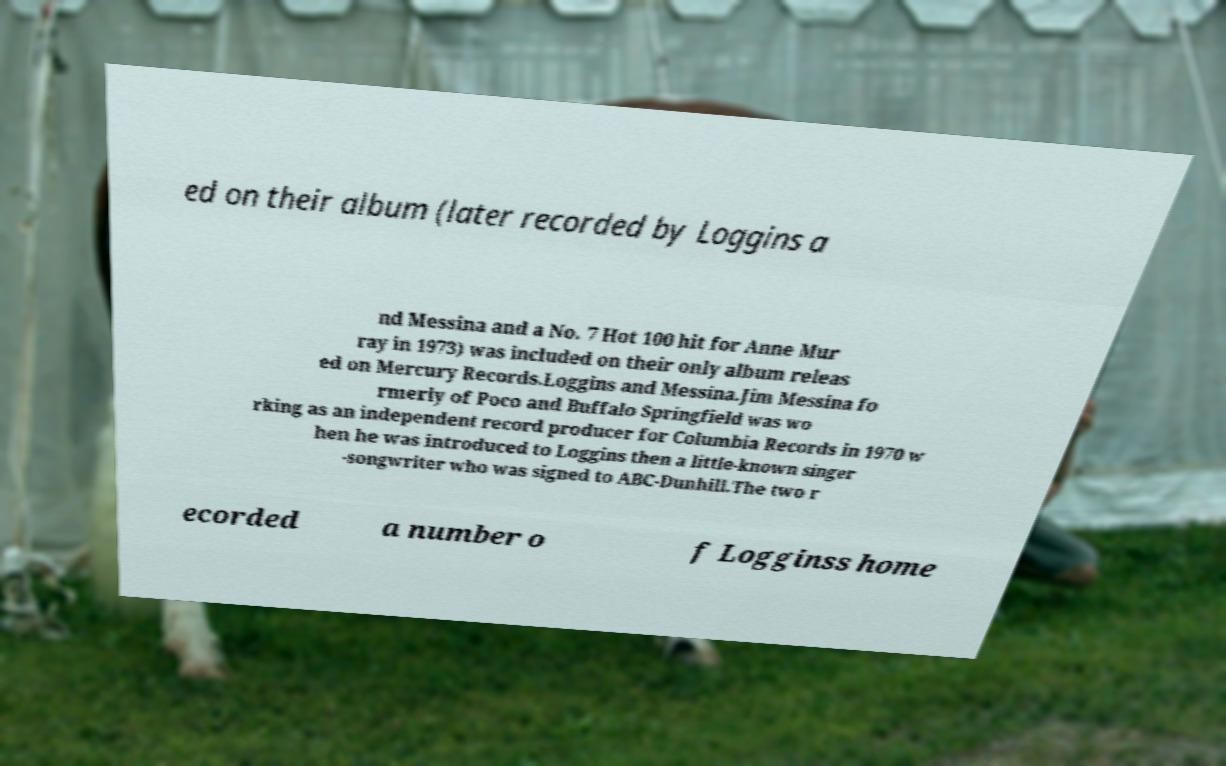Can you read and provide the text displayed in the image?This photo seems to have some interesting text. Can you extract and type it out for me? ed on their album (later recorded by Loggins a nd Messina and a No. 7 Hot 100 hit for Anne Mur ray in 1973) was included on their only album releas ed on Mercury Records.Loggins and Messina.Jim Messina fo rmerly of Poco and Buffalo Springfield was wo rking as an independent record producer for Columbia Records in 1970 w hen he was introduced to Loggins then a little-known singer -songwriter who was signed to ABC-Dunhill.The two r ecorded a number o f Logginss home 